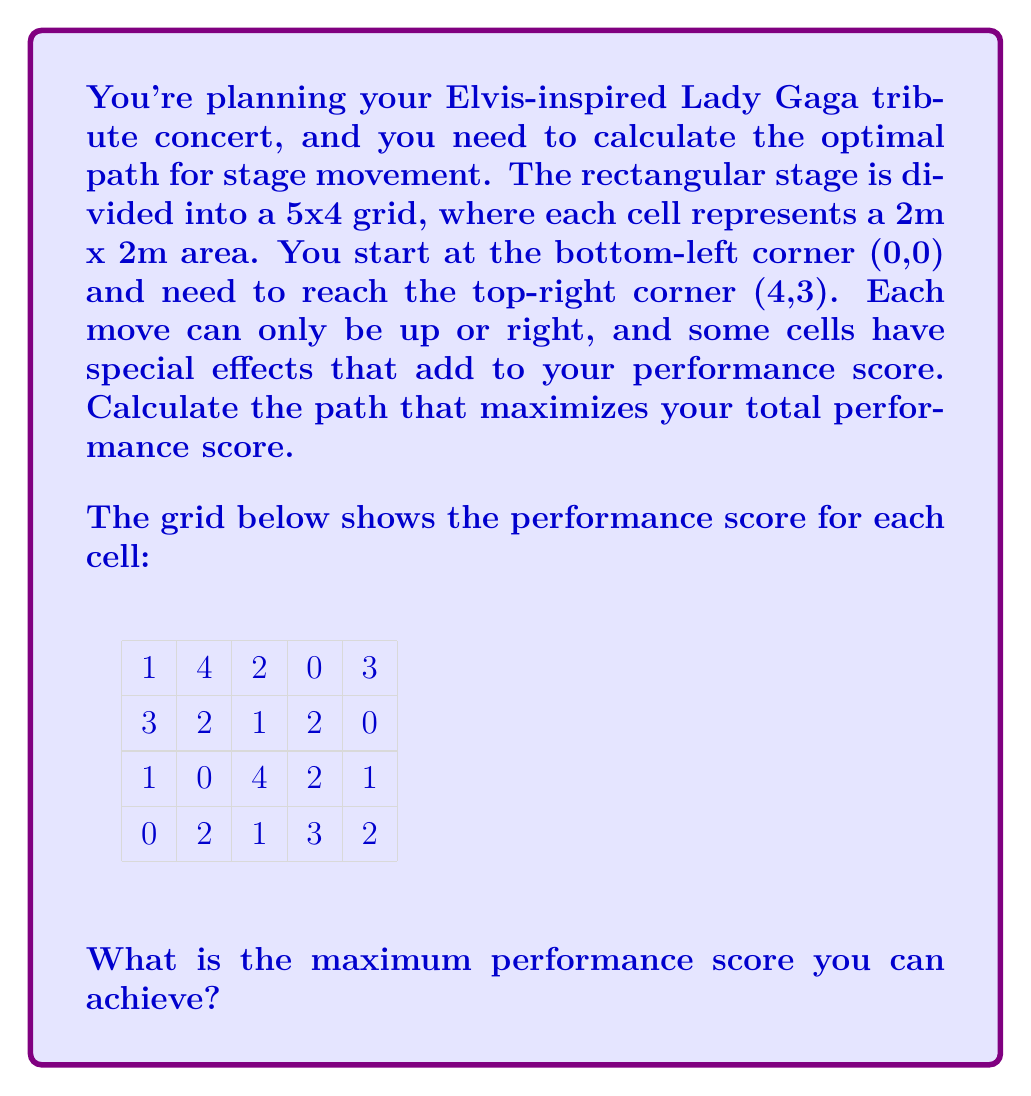Provide a solution to this math problem. To solve this problem, we'll use dynamic programming. We'll create a table where each cell represents the maximum score that can be achieved when reaching that cell. We'll fill this table from bottom-left to top-right.

Let $dp[i][j]$ represent the maximum score at cell $(i,j)$.

Base case:
$dp[0][0] = \text{score of cell (0,0)} = 0$

For the first row and column:
$dp[i][0] = dp[i-1][0] + \text{score of cell (i,0)}$ for $i > 0$
$dp[0][j] = dp[0][j-1] + \text{score of cell (0,j)}$ for $j > 0$

For all other cells:
$dp[i][j] = \max(dp[i-1][j], dp[i][j-1]) + \text{score of cell (i,j)}$

Let's fill the table:

$$
\begin{array}{c|ccccc}
3 & 1 & 5 & 7 & 7 & \mathbf{10} \\
2 & 4 & 6 & 7 & 9 & 9 \\
1 & 1 & 1 & 5 & 7 & 8 \\
0 & 0 & 2 & 3 & 6 & 8 \\
\hline
  & 0 & 1 & 2 & 3 & 4
\end{array}
$$

The maximum score is in the top-right cell, which is 10.
Answer: The maximum performance score that can be achieved is 10. 